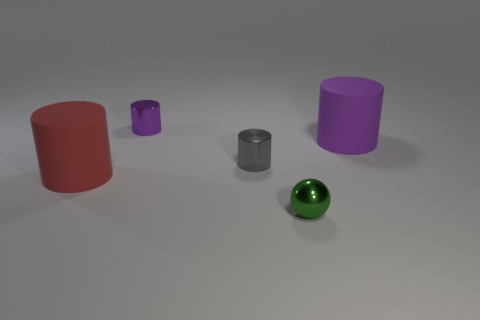There is a large thing that is behind the big cylinder left of the tiny gray metallic cylinder; what is its shape?
Make the answer very short. Cylinder. Does the cylinder that is on the right side of the metal ball have the same size as the small gray shiny thing?
Provide a succinct answer. No. What size is the thing that is both behind the tiny gray metallic object and to the right of the small gray metal object?
Give a very brief answer. Large. What number of red things are the same size as the green ball?
Make the answer very short. 0. What number of purple rubber things are on the left side of the small metallic cylinder behind the gray metal thing?
Your response must be concise. 0. Is the color of the big rubber thing that is on the right side of the metal sphere the same as the ball?
Offer a terse response. No. Is there a purple shiny object that is in front of the purple cylinder on the right side of the tiny metallic cylinder that is to the left of the small gray shiny thing?
Your answer should be very brief. No. What shape is the object that is both right of the tiny purple metallic cylinder and in front of the gray cylinder?
Provide a short and direct response. Sphere. Are there any big rubber cylinders that have the same color as the shiny ball?
Ensure brevity in your answer.  No. What is the color of the big object in front of the rubber thing behind the large red cylinder?
Your answer should be compact. Red. 